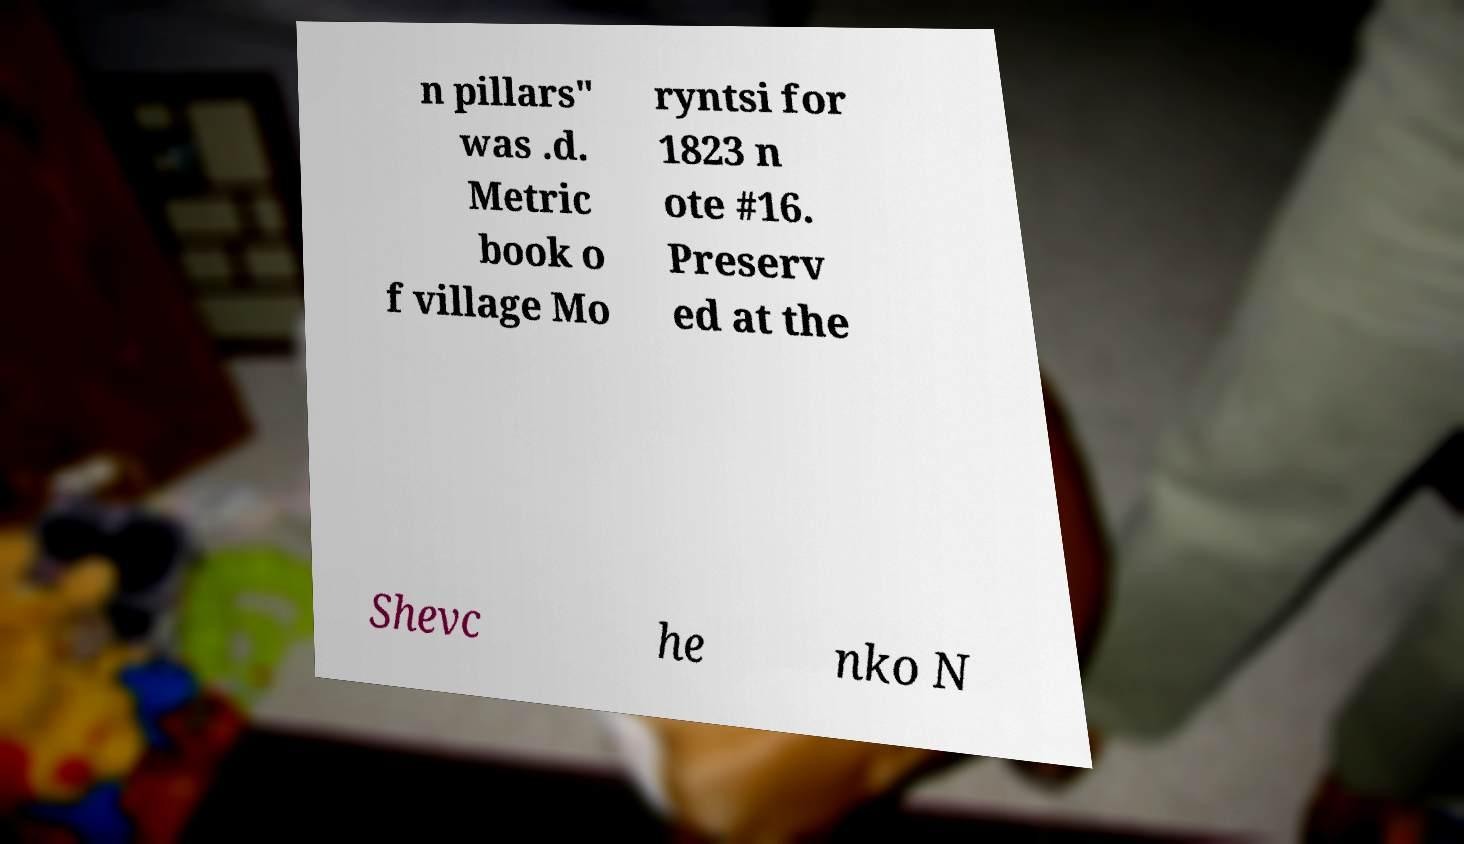Can you accurately transcribe the text from the provided image for me? n pillars" was .d. Metric book o f village Mo ryntsi for 1823 n ote #16. Preserv ed at the Shevc he nko N 